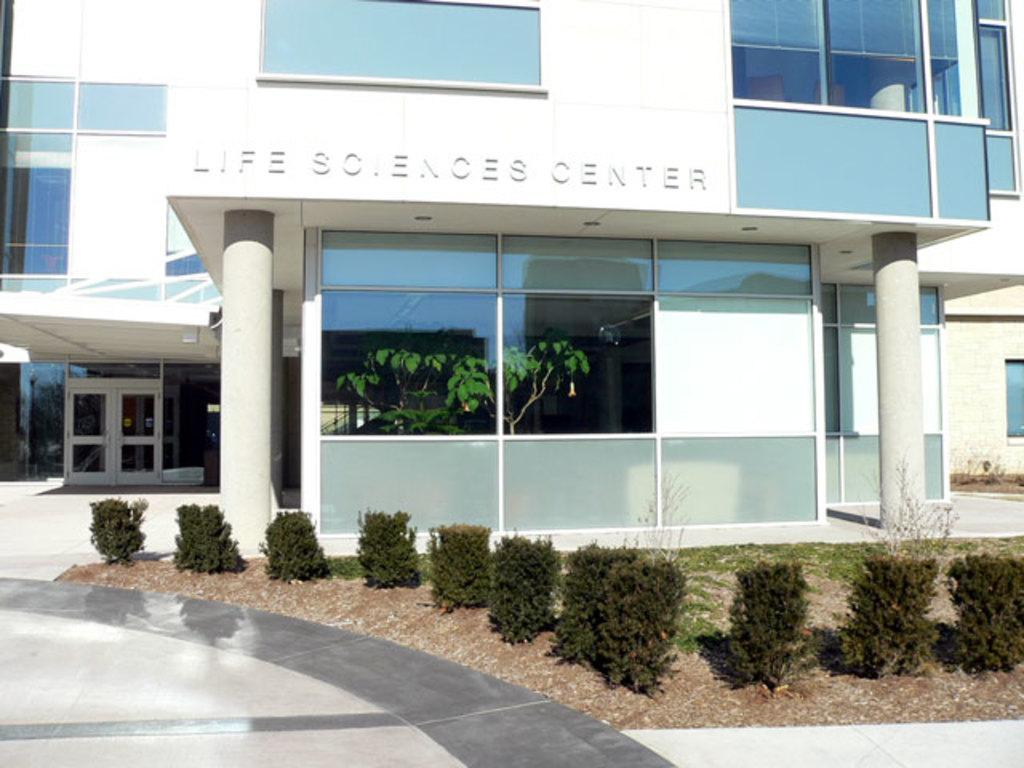What type of structure can be seen in the background of the image? There is a building with pillars in the background of the image. What is visible at the bottom of the image? There is a floor visible at the bottom of the image. What type of natural elements are present in the image? There are plants in the image. What type of suit can be seen hanging on the plants in the image? There is no suit present in the image, and the plants are not holding any clothing items. 